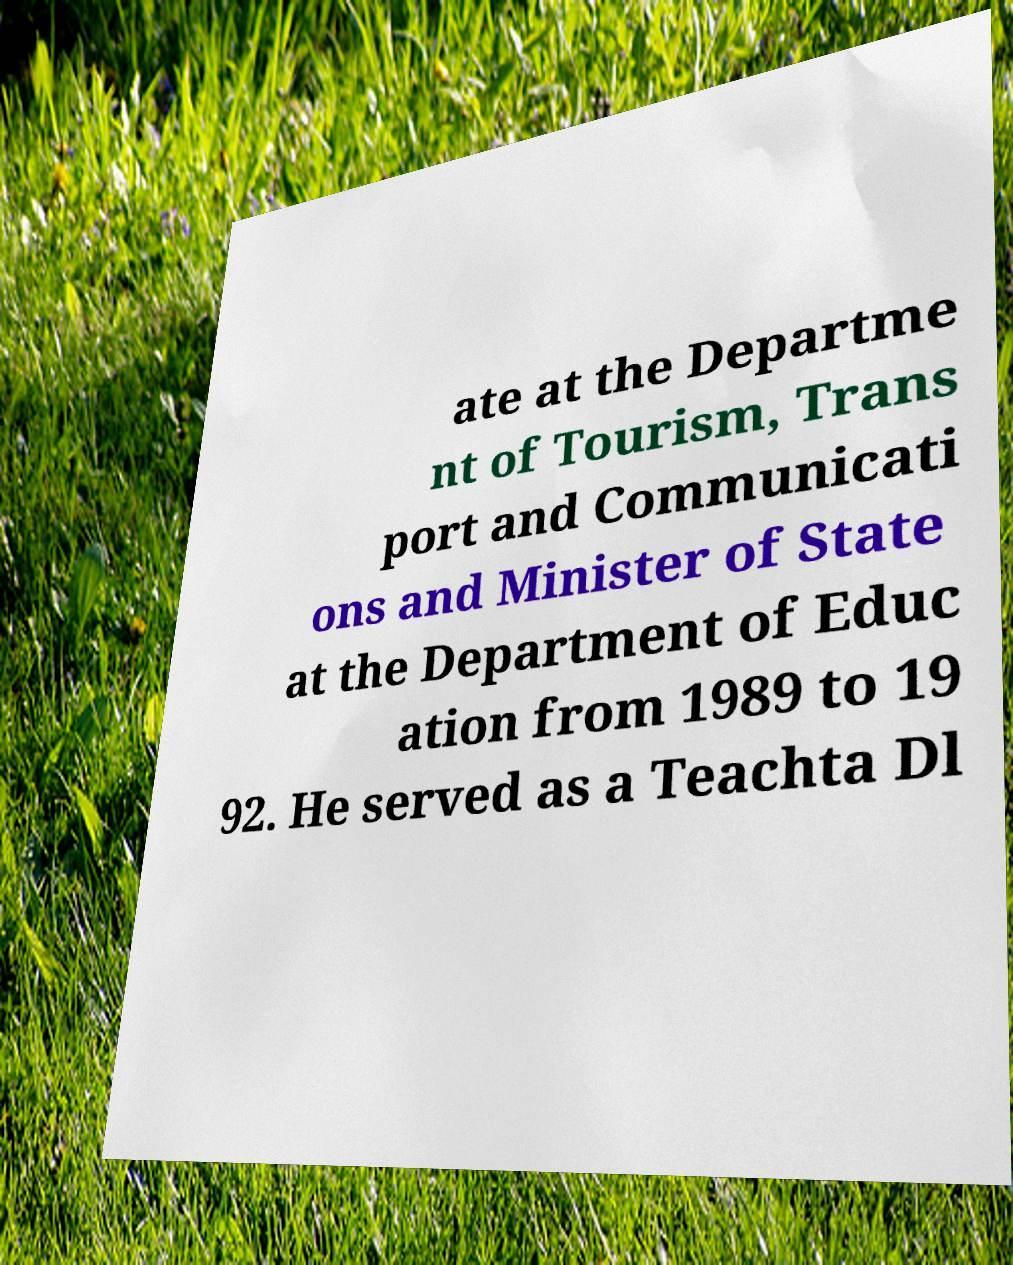Please identify and transcribe the text found in this image. ate at the Departme nt of Tourism, Trans port and Communicati ons and Minister of State at the Department of Educ ation from 1989 to 19 92. He served as a Teachta Dl 